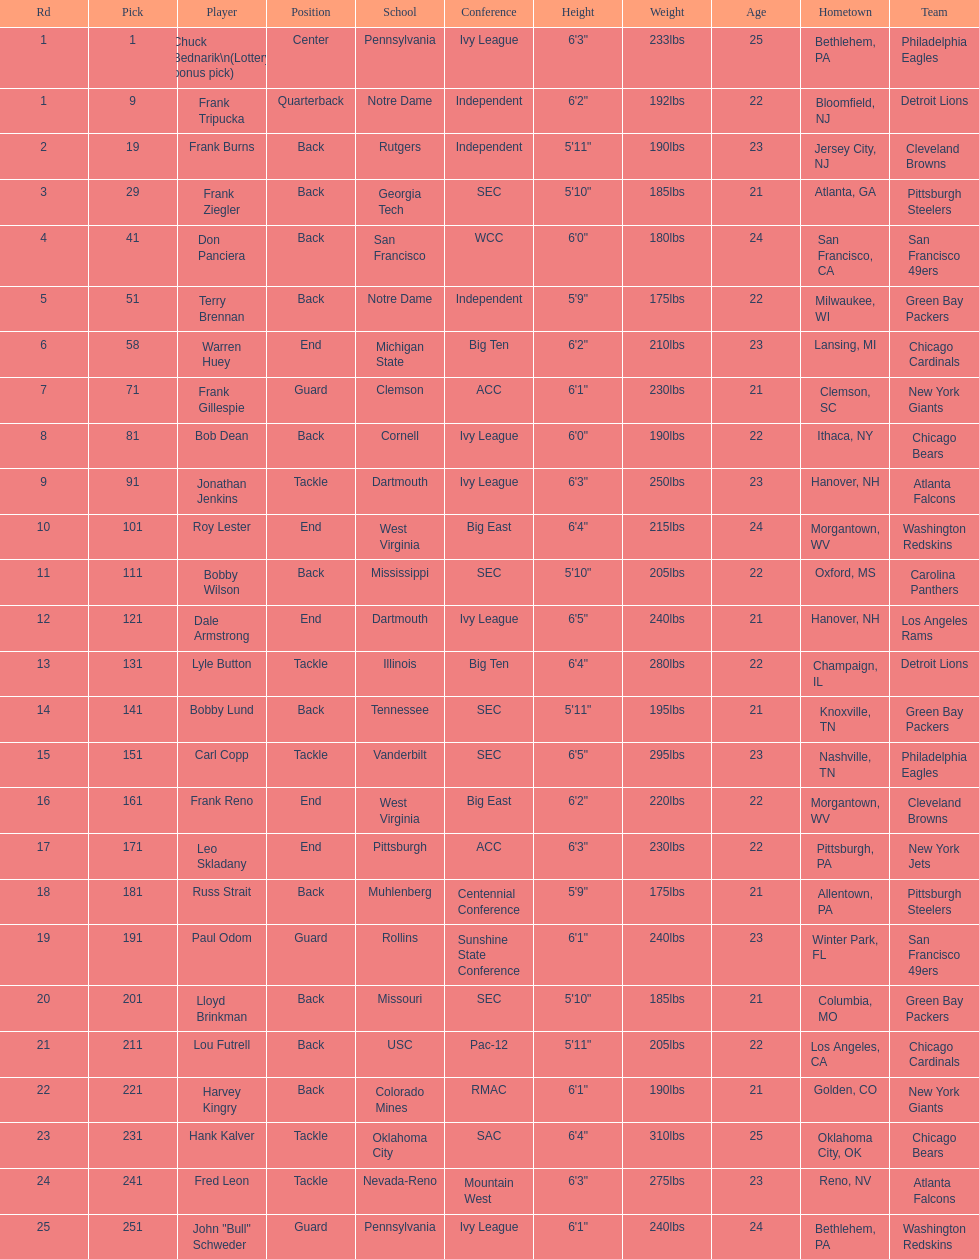How many players were from notre dame? 2. 